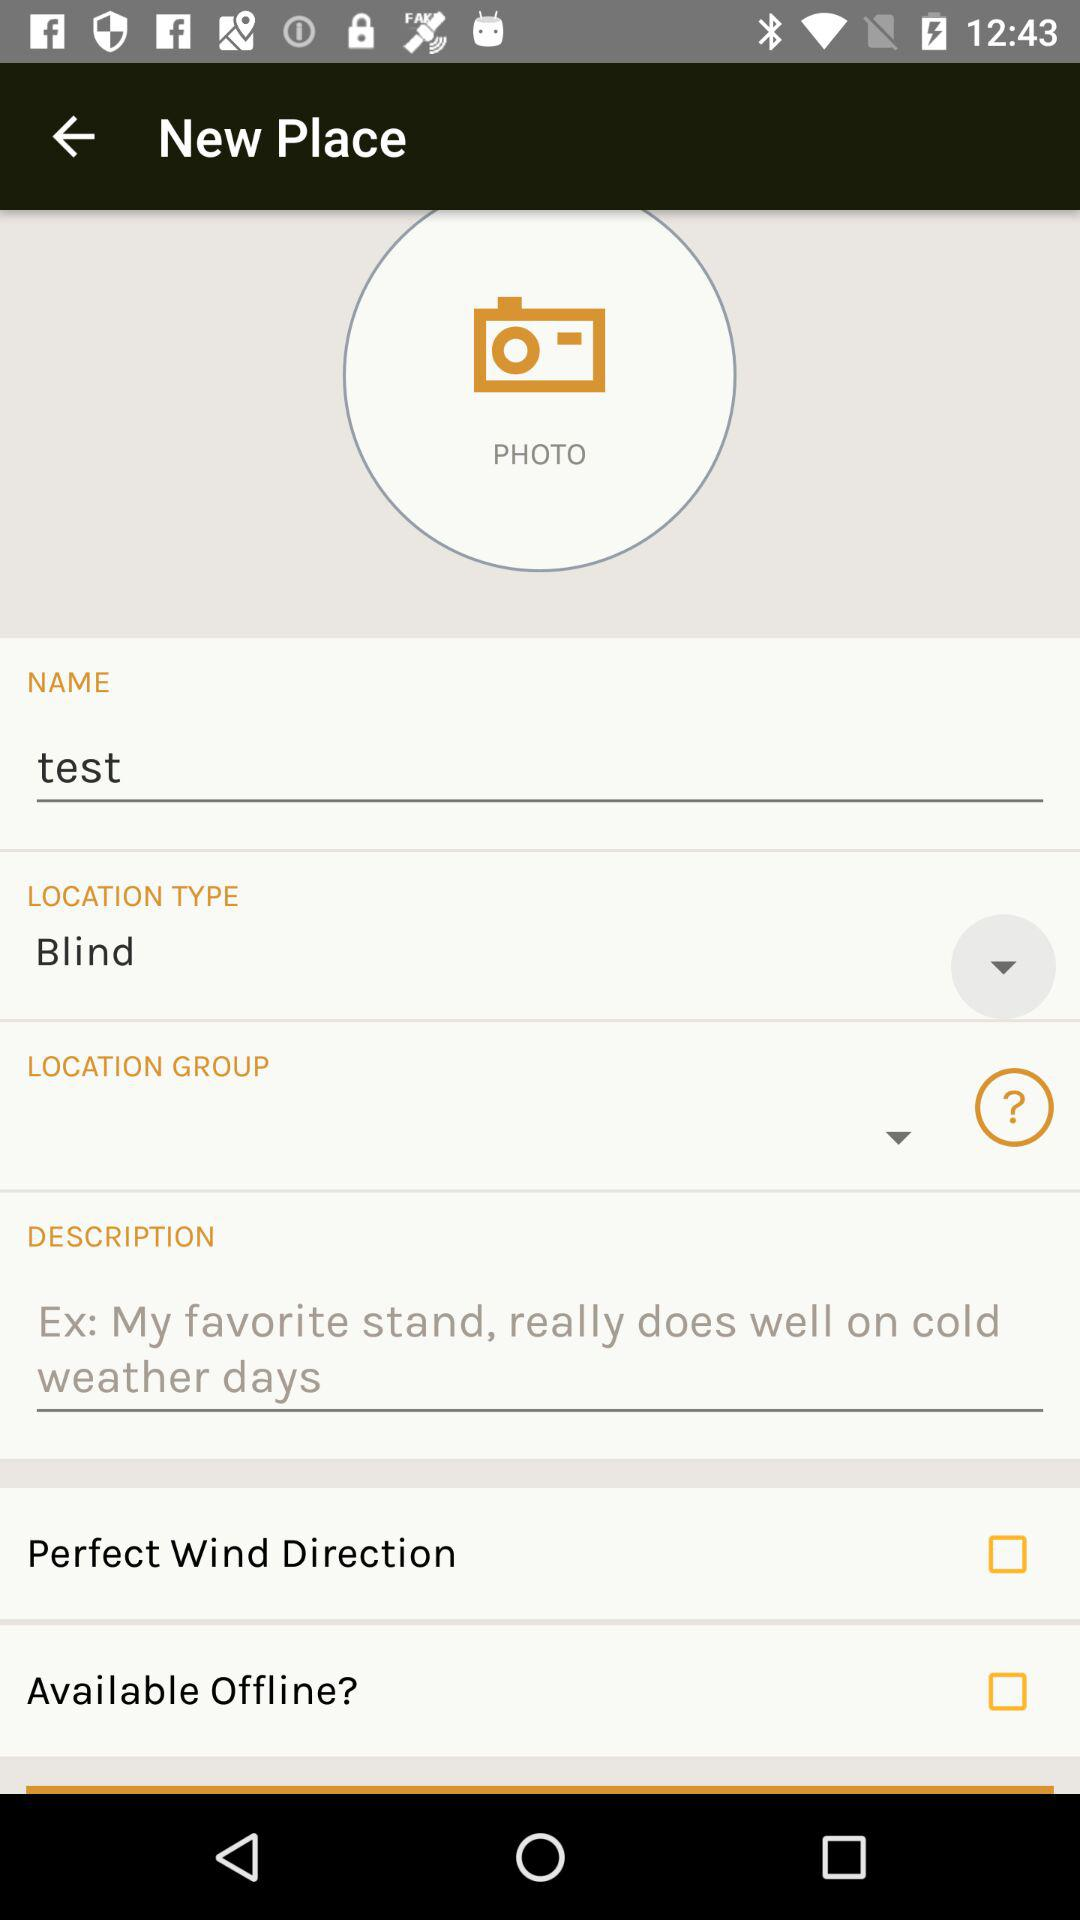What is the current status of the "Available Offline?"? The current status of the "Available Offline?" is "off". 